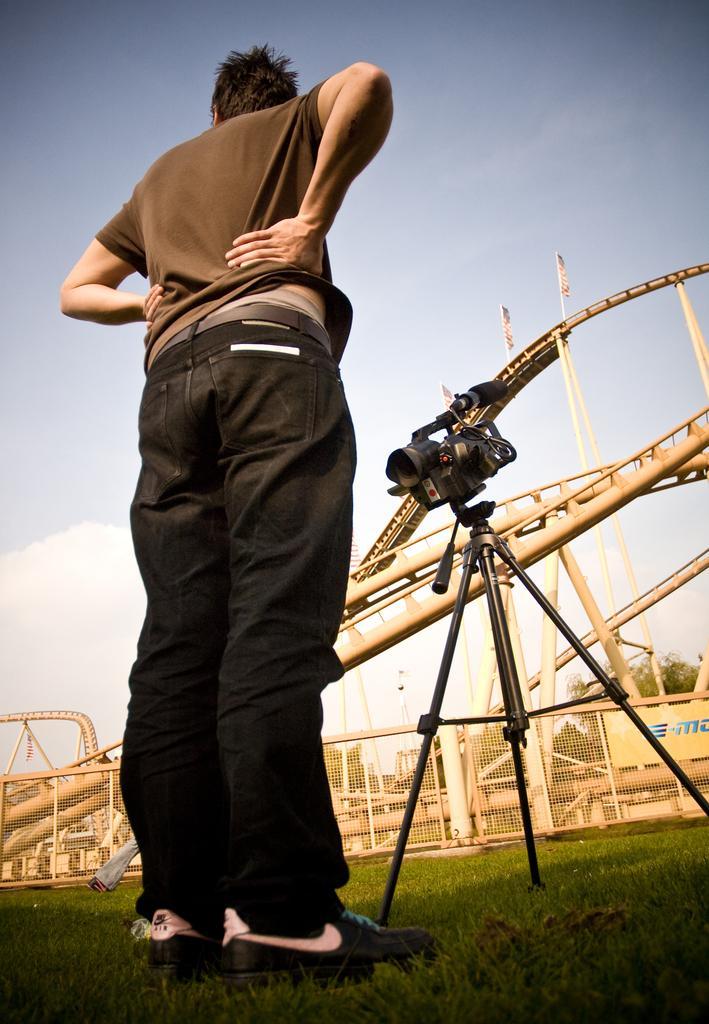Could you give a brief overview of what you see in this image? In this picture we can see a person standing on the grass, camera on a tripod stand, poster, fence, poles, flags, trees and some objects and in the background we can see the sky. 